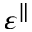<formula> <loc_0><loc_0><loc_500><loc_500>\varepsilon ^ { \| }</formula> 